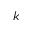Convert formula to latex. <formula><loc_0><loc_0><loc_500><loc_500>k</formula> 